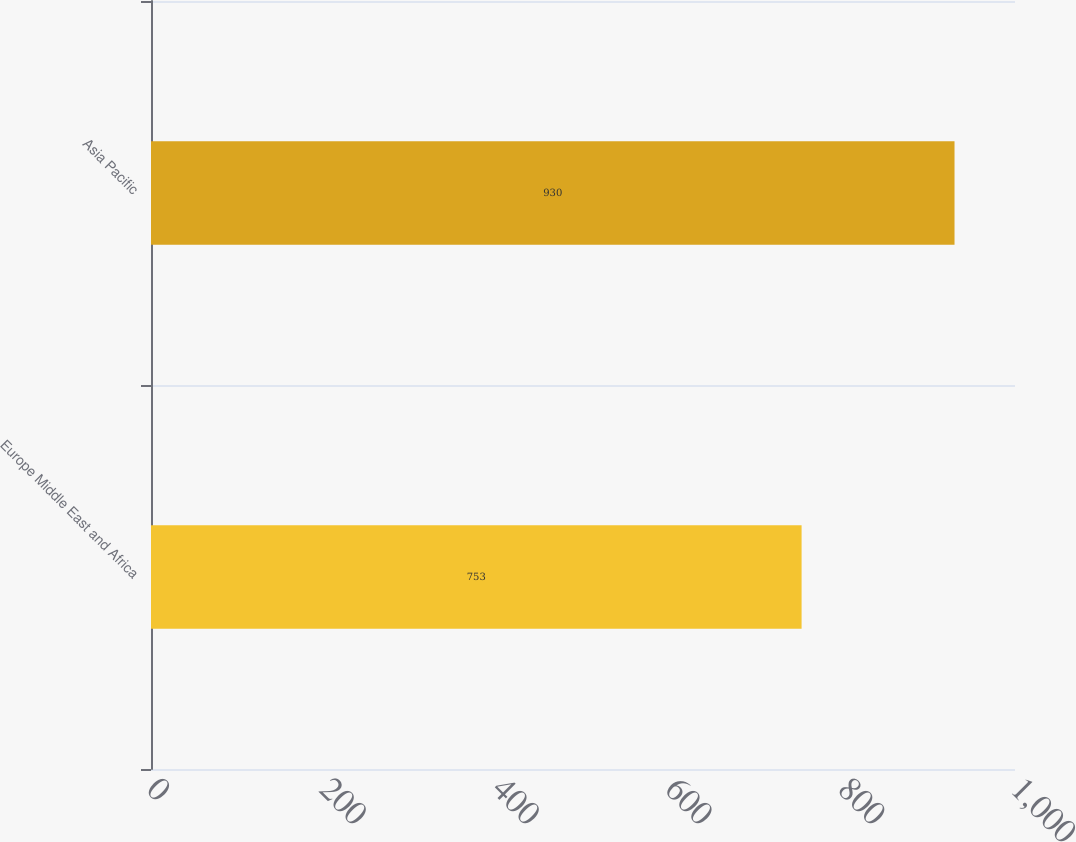Convert chart. <chart><loc_0><loc_0><loc_500><loc_500><bar_chart><fcel>Europe Middle East and Africa<fcel>Asia Pacific<nl><fcel>753<fcel>930<nl></chart> 